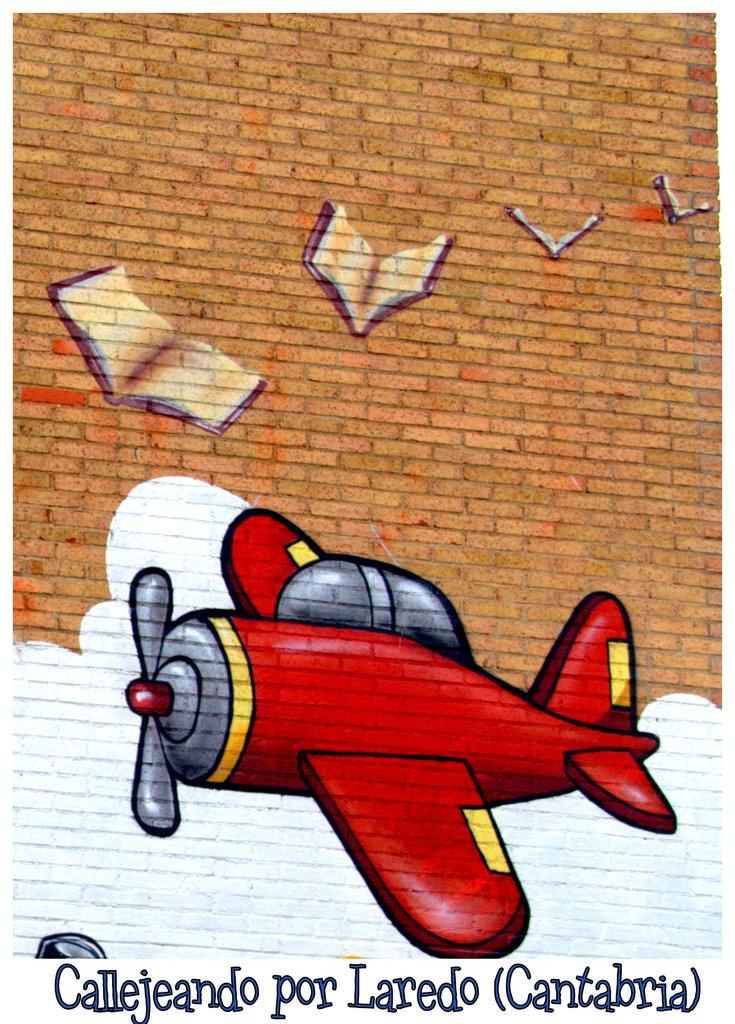What is the main subject in the center of the image? There is an aeroplane in the center of the image. What can be seen at the top of the image? There is a wall at the top of the image. What objects are near the wall? Books are present near the wall. What is written or depicted at the bottom of the image? There is some text at the bottom of the image. Where is the stove located in the image? There is no stove present in the image. What type of salt can be seen on the aeroplane? There is no salt visible in the image, as it features an aeroplane, a wall, books, and text. 